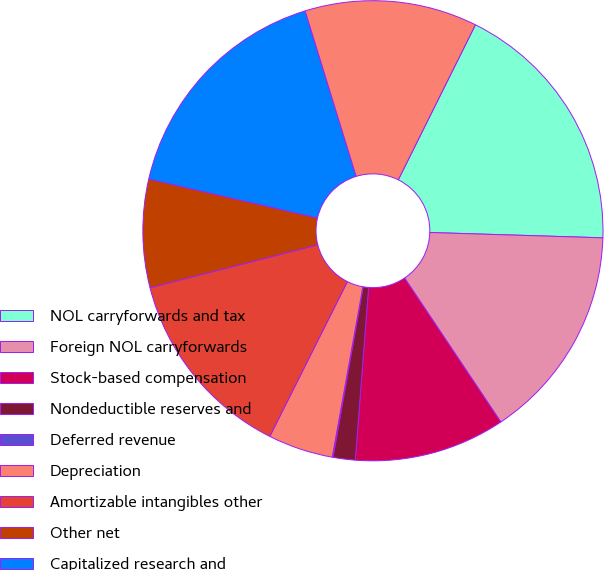Convert chart to OTSL. <chart><loc_0><loc_0><loc_500><loc_500><pie_chart><fcel>NOL carryforwards and tax<fcel>Foreign NOL carryforwards<fcel>Stock-based compensation<fcel>Nondeductible reserves and<fcel>Deferred revenue<fcel>Depreciation<fcel>Amortizable intangibles other<fcel>Other net<fcel>Capitalized research and<fcel>Identified intangibles<nl><fcel>18.14%<fcel>15.13%<fcel>10.6%<fcel>1.56%<fcel>0.05%<fcel>4.57%<fcel>13.62%<fcel>7.59%<fcel>16.63%<fcel>12.11%<nl></chart> 